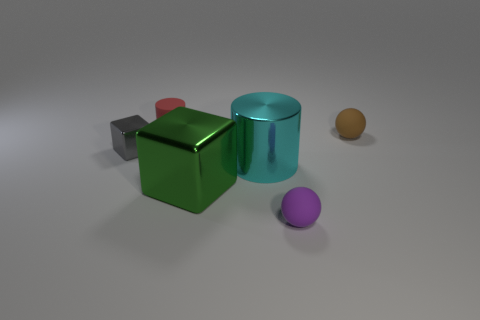Subtract all yellow balls. Subtract all purple cylinders. How many balls are left? 2 Add 3 cyan objects. How many objects exist? 9 Subtract all balls. How many objects are left? 4 Add 5 cyan shiny objects. How many cyan shiny objects are left? 6 Add 2 blue metal spheres. How many blue metal spheres exist? 2 Subtract 0 blue cylinders. How many objects are left? 6 Subtract all small purple matte spheres. Subtract all large rubber blocks. How many objects are left? 5 